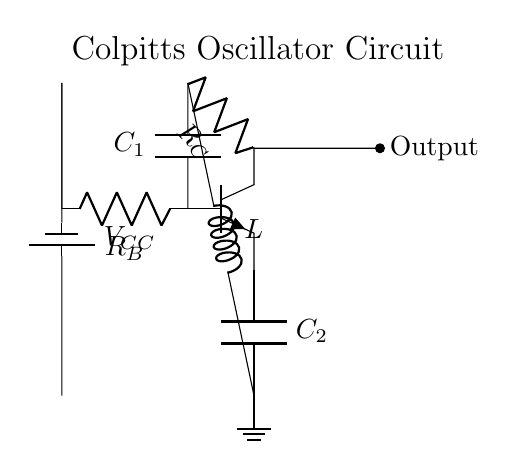What type of oscillator is depicted in the circuit? The circuit shown is a Colpitts oscillator, as indicated by the specific arrangement of capacitors and an inductor in the feedback loop, which is characteristic of this type of oscillator.
Answer: Colpitts oscillator What are the capacitor values present in the circuit? The circuit includes two capacitors labeled C1 and C2. Their exact values are not provided in the visual, but they are crucial components for determining the oscillation frequency.
Answer: C1 and C2 What component connects the emitter of the transistor to the ground? The ground connection is realized through capacitor C2, which links the emitter of the transistor to the circuit's ground reference.
Answer: C2 How many resistors are present in the circuit? The circuit features two resistors: one connected to the collector (RC) and another one connected to the base (RB), a total of two.
Answer: 2 What is the role of the inductor in the circuit? The inductor L is part of the tank circuit along with capacitors C1 and C2, determining the frequency of oscillation based on the formula for resonant frequency, making it essential for signal generation.
Answer: Frequency determination What is the function of the power supply in the circuit? The power supply, represented as VCC, provides the necessary bias current for the transistor to operate in its active region, which is essential for amplification in this oscillator configuration.
Answer: Bias current Which component represents the output of the oscillator? The output of the oscillator is taken from the collector of the transistor, where a short line indicates the signal output point.
Answer: Collector of the transistor 